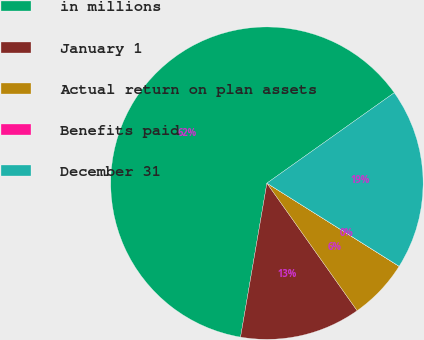Convert chart to OTSL. <chart><loc_0><loc_0><loc_500><loc_500><pie_chart><fcel>in millions<fcel>January 1<fcel>Actual return on plan assets<fcel>Benefits paid<fcel>December 31<nl><fcel>62.47%<fcel>12.5%<fcel>6.26%<fcel>0.01%<fcel>18.75%<nl></chart> 